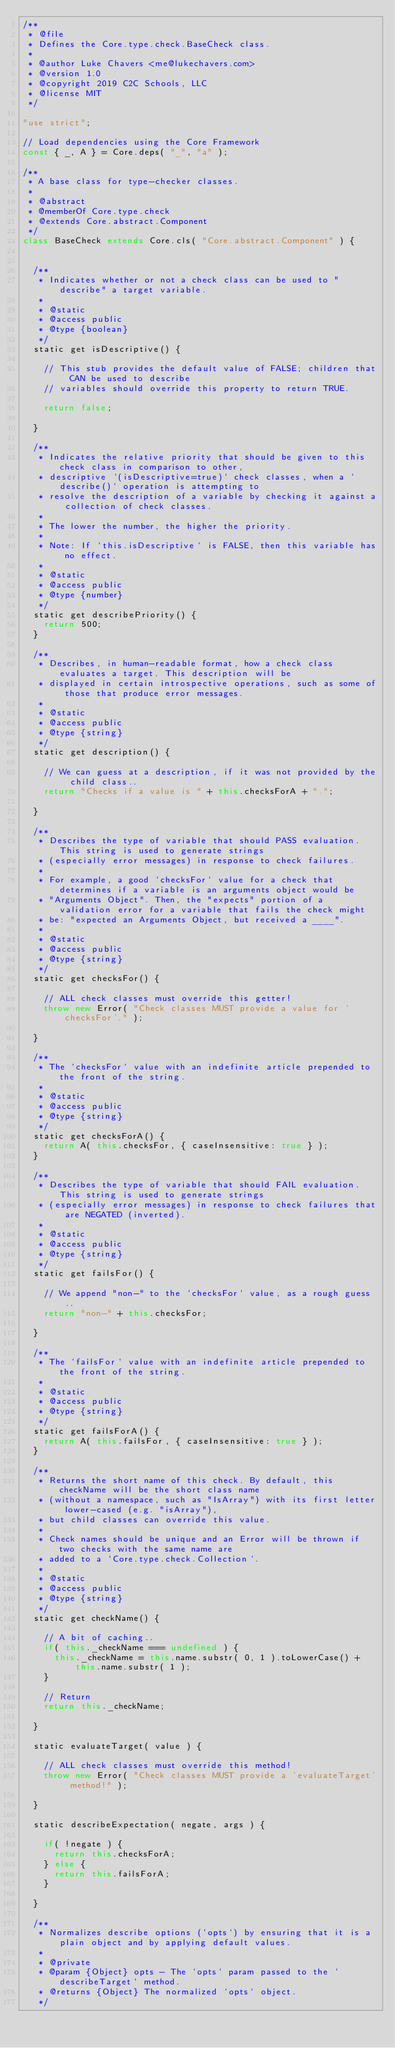Convert code to text. <code><loc_0><loc_0><loc_500><loc_500><_JavaScript_>/**
 * @file
 * Defines the Core.type.check.BaseCheck class.
 *
 * @author Luke Chavers <me@lukechavers.com>
 * @version 1.0
 * @copyright 2019 C2C Schools, LLC
 * @license MIT
 */

"use strict";

// Load dependencies using the Core Framework
const { _, A } = Core.deps( "_", "a" );

/**
 * A base class for type-checker classes.
 *
 * @abstract
 * @memberOf Core.type.check
 * @extends Core.abstract.Component
 */
class BaseCheck extends Core.cls( "Core.abstract.Component" ) {


	/**
	 * Indicates whether or not a check class can be used to "describe" a target variable.
	 *
	 * @static
	 * @access public
	 * @type {boolean}
	 */
	static get isDescriptive() {

		// This stub provides the default value of FALSE; children that CAN be used to describe
		// variables should override this property to return TRUE.

		return false;

	}

	/**
	 * Indicates the relative priority that should be given to this check class in comparison to other,
	 * descriptive `(isDescriptive=true)` check classes, when a `describe()` operation is attempting to
	 * resolve the description of a variable by checking it against a collection of check classes.
	 *
	 * The lower the number, the higher the priority.
	 *
	 * Note: If `this.isDescriptive` is FALSE, then this variable has no effect.
	 *
	 * @static
	 * @access public
	 * @type {number}
	 */
	static get describePriority() {
		return 500;
	}

	/**
	 * Describes, in human-readable format, how a check class evaluates a target. This description will be
	 * displayed in certain introspective operations, such as some of those that produce error messages.
	 *
	 * @static
	 * @access public
	 * @type {string}
	 */
	static get description() {

		// We can guess at a description, if it was not provided by the child class..
		return "Checks if a value is " + this.checksForA + ".";

	}

	/**
	 * Describes the type of variable that should PASS evaluation. This string is used to generate strings
	 * (especially error messages) in response to check failures.
	 *
	 * For example, a good `checksFor` value for a check that determines if a variable is an arguments object would be
	 * "Arguments Object". Then, the "expects" portion of a validation error for a variable that fails the check might
	 * be: "expected an Arguments Object, but received a ____".
	 *
	 * @static
	 * @access public
	 * @type {string}
	 */
	static get checksFor() {

		// ALL check classes must override this getter!
		throw new Error( "Check classes MUST provide a value for 'checksFor'." );

	}

	/**
	 * The `checksFor` value with an indefinite article prepended to the front of the string.
	 *
	 * @static
	 * @access public
	 * @type {string}
	 */
	static get checksForA() {
		return A( this.checksFor, { caseInsensitive: true } );
	}

	/**
	 * Describes the type of variable that should FAIL evaluation. This string is used to generate strings
	 * (especially error messages) in response to check failures that are NEGATED (inverted).
	 *
	 * @static
	 * @access public
	 * @type {string}
	 */
	static get failsFor() {

		// We append "non-" to the `checksFor` value, as a rough guess..
		return "non-" + this.checksFor;

	}

	/**
	 * The `failsFor` value with an indefinite article prepended to the front of the string.
	 *
	 * @static
	 * @access public
	 * @type {string}
	 */
	static get failsForA() {
		return A( this.failsFor, { caseInsensitive: true } );
	}

	/**
	 * Returns the short name of this check. By default, this checkName will be the short class name
	 * (without a namespace, such as "IsArray") with its first letter lower-cased (e.g. "isArray"),
	 * but child classes can override this value.
	 *
	 * Check names should be unique and an Error will be thrown if two checks with the same name are
	 * added to a `Core.type.check.Collection`.
	 *
	 * @static
	 * @access public
	 * @type {string}
	 */
	static get checkName() {

		// A bit of caching..
		if( this._checkName === undefined ) {
			this._checkName = this.name.substr( 0, 1 ).toLowerCase() + this.name.substr( 1 );
		}

		// Return
		return this._checkName;

	}

	static evaluateTarget( value ) {

		// ALL check classes must override this method!
		throw new Error( "Check classes MUST provide a 'evaluateTarget' method!" );

	}

	static describeExpectation( negate, args ) {

		if( !negate ) {
			return this.checksForA;
		} else {
			return this.failsForA;
		}

	}

	/**
	 * Normalizes describe options (`opts`) by ensuring that it is a plain object and by applying default values.
	 *
	 * @private
	 * @param {Object} opts - The `opts` param passed to the `describeTarget` method.
	 * @returns {Object} The normalized `opts` object.
	 */</code> 